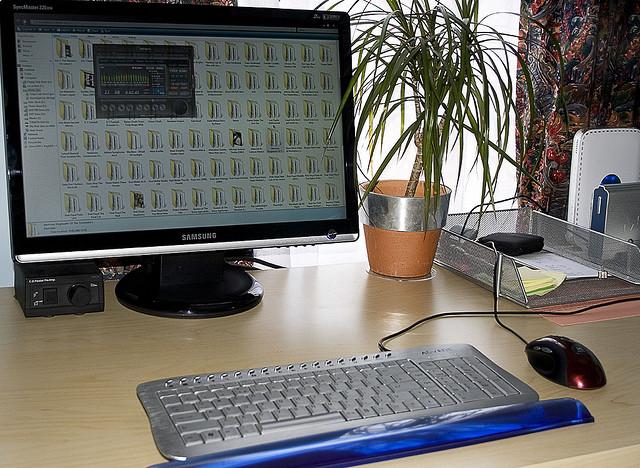Is the mouse or the monitor closer to the keyboard?
Be succinct. Mouse. What is the name of the plant seen in the picture?
Answer briefly. Palm. What type of flowers are in the vase?
Concise answer only. Palm. Is the background clear?
Concise answer only. Yes. Are there many folders?
Answer briefly. Yes. 